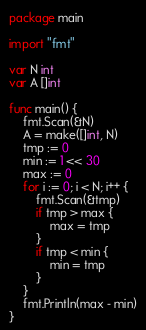Convert code to text. <code><loc_0><loc_0><loc_500><loc_500><_Go_>package main

import "fmt"

var N int
var A []int

func main() {
	fmt.Scan(&N)
	A = make([]int, N)
	tmp := 0
	min := 1 << 30
	max := 0
	for i := 0; i < N; i++ {
		fmt.Scan(&tmp)
		if tmp > max {
			max = tmp
		}
		if tmp < min {
			min = tmp
		}
	}
	fmt.Println(max - min)
}
</code> 